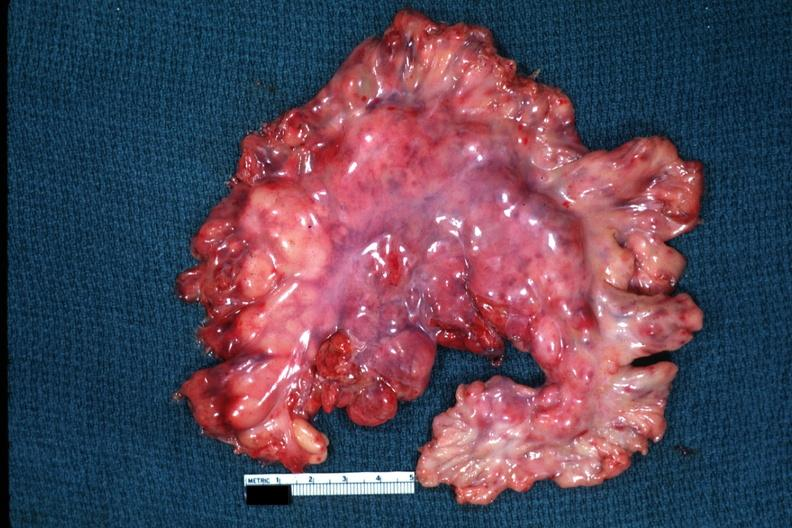s fat necrosis present?
Answer the question using a single word or phrase. No 